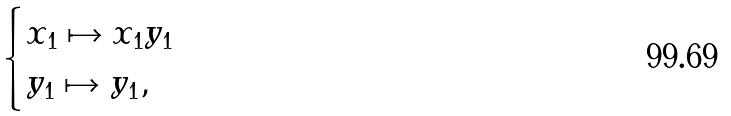<formula> <loc_0><loc_0><loc_500><loc_500>\begin{cases} x _ { 1 } \mapsto x _ { 1 } y _ { 1 } \\ y _ { 1 } \mapsto y _ { 1 } , \end{cases}</formula> 